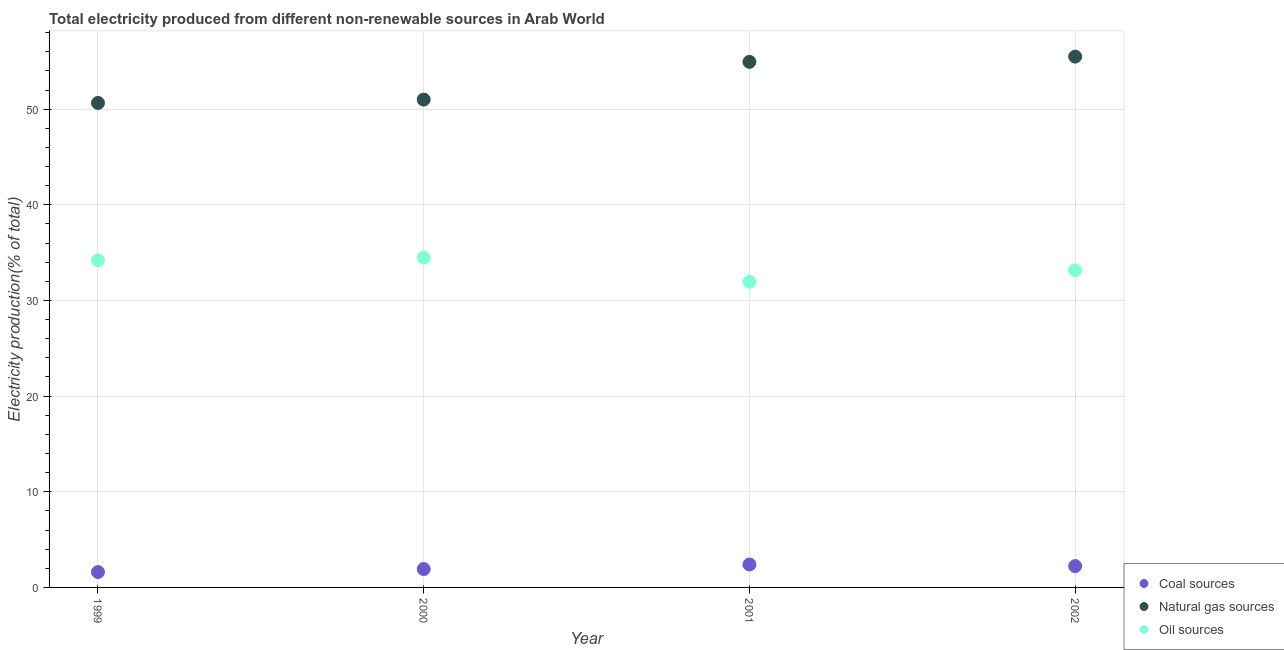What is the percentage of electricity produced by natural gas in 2002?
Offer a terse response. 55.49. Across all years, what is the maximum percentage of electricity produced by natural gas?
Offer a terse response. 55.49. Across all years, what is the minimum percentage of electricity produced by natural gas?
Provide a succinct answer. 50.65. What is the total percentage of electricity produced by oil sources in the graph?
Give a very brief answer. 133.8. What is the difference between the percentage of electricity produced by oil sources in 1999 and that in 2000?
Your response must be concise. -0.27. What is the difference between the percentage of electricity produced by oil sources in 2002 and the percentage of electricity produced by coal in 2000?
Keep it short and to the point. 31.23. What is the average percentage of electricity produced by coal per year?
Provide a short and direct response. 2.04. In the year 2002, what is the difference between the percentage of electricity produced by natural gas and percentage of electricity produced by oil sources?
Ensure brevity in your answer.  22.34. What is the ratio of the percentage of electricity produced by oil sources in 2000 to that in 2002?
Your answer should be very brief. 1.04. What is the difference between the highest and the second highest percentage of electricity produced by natural gas?
Your answer should be very brief. 0.55. What is the difference between the highest and the lowest percentage of electricity produced by natural gas?
Your response must be concise. 4.85. Is the sum of the percentage of electricity produced by oil sources in 1999 and 2001 greater than the maximum percentage of electricity produced by natural gas across all years?
Your answer should be very brief. Yes. Does the percentage of electricity produced by natural gas monotonically increase over the years?
Your answer should be compact. Yes. Are the values on the major ticks of Y-axis written in scientific E-notation?
Offer a very short reply. No. Does the graph contain any zero values?
Provide a short and direct response. No. Does the graph contain grids?
Provide a succinct answer. Yes. Where does the legend appear in the graph?
Keep it short and to the point. Bottom right. How are the legend labels stacked?
Ensure brevity in your answer.  Vertical. What is the title of the graph?
Provide a short and direct response. Total electricity produced from different non-renewable sources in Arab World. What is the label or title of the Y-axis?
Give a very brief answer. Electricity production(% of total). What is the Electricity production(% of total) in Coal sources in 1999?
Ensure brevity in your answer.  1.61. What is the Electricity production(% of total) of Natural gas sources in 1999?
Provide a short and direct response. 50.65. What is the Electricity production(% of total) in Oil sources in 1999?
Your answer should be very brief. 34.21. What is the Electricity production(% of total) of Coal sources in 2000?
Keep it short and to the point. 1.92. What is the Electricity production(% of total) of Natural gas sources in 2000?
Provide a short and direct response. 51. What is the Electricity production(% of total) of Oil sources in 2000?
Offer a very short reply. 34.48. What is the Electricity production(% of total) in Coal sources in 2001?
Provide a succinct answer. 2.4. What is the Electricity production(% of total) of Natural gas sources in 2001?
Provide a succinct answer. 54.94. What is the Electricity production(% of total) in Oil sources in 2001?
Your answer should be compact. 31.96. What is the Electricity production(% of total) of Coal sources in 2002?
Ensure brevity in your answer.  2.23. What is the Electricity production(% of total) in Natural gas sources in 2002?
Provide a short and direct response. 55.49. What is the Electricity production(% of total) of Oil sources in 2002?
Give a very brief answer. 33.15. Across all years, what is the maximum Electricity production(% of total) of Coal sources?
Your answer should be compact. 2.4. Across all years, what is the maximum Electricity production(% of total) of Natural gas sources?
Ensure brevity in your answer.  55.49. Across all years, what is the maximum Electricity production(% of total) of Oil sources?
Provide a succinct answer. 34.48. Across all years, what is the minimum Electricity production(% of total) in Coal sources?
Provide a short and direct response. 1.61. Across all years, what is the minimum Electricity production(% of total) in Natural gas sources?
Your response must be concise. 50.65. Across all years, what is the minimum Electricity production(% of total) in Oil sources?
Offer a terse response. 31.96. What is the total Electricity production(% of total) of Coal sources in the graph?
Your answer should be compact. 8.15. What is the total Electricity production(% of total) in Natural gas sources in the graph?
Your answer should be compact. 212.08. What is the total Electricity production(% of total) of Oil sources in the graph?
Ensure brevity in your answer.  133.8. What is the difference between the Electricity production(% of total) of Coal sources in 1999 and that in 2000?
Give a very brief answer. -0.31. What is the difference between the Electricity production(% of total) in Natural gas sources in 1999 and that in 2000?
Offer a very short reply. -0.35. What is the difference between the Electricity production(% of total) of Oil sources in 1999 and that in 2000?
Your answer should be compact. -0.27. What is the difference between the Electricity production(% of total) of Coal sources in 1999 and that in 2001?
Your answer should be compact. -0.79. What is the difference between the Electricity production(% of total) of Natural gas sources in 1999 and that in 2001?
Give a very brief answer. -4.29. What is the difference between the Electricity production(% of total) of Oil sources in 1999 and that in 2001?
Offer a very short reply. 2.25. What is the difference between the Electricity production(% of total) in Coal sources in 1999 and that in 2002?
Ensure brevity in your answer.  -0.62. What is the difference between the Electricity production(% of total) of Natural gas sources in 1999 and that in 2002?
Your answer should be very brief. -4.85. What is the difference between the Electricity production(% of total) of Oil sources in 1999 and that in 2002?
Your answer should be very brief. 1.06. What is the difference between the Electricity production(% of total) of Coal sources in 2000 and that in 2001?
Provide a short and direct response. -0.48. What is the difference between the Electricity production(% of total) in Natural gas sources in 2000 and that in 2001?
Your response must be concise. -3.94. What is the difference between the Electricity production(% of total) in Oil sources in 2000 and that in 2001?
Provide a short and direct response. 2.52. What is the difference between the Electricity production(% of total) in Coal sources in 2000 and that in 2002?
Give a very brief answer. -0.31. What is the difference between the Electricity production(% of total) in Natural gas sources in 2000 and that in 2002?
Give a very brief answer. -4.49. What is the difference between the Electricity production(% of total) of Oil sources in 2000 and that in 2002?
Give a very brief answer. 1.33. What is the difference between the Electricity production(% of total) of Coal sources in 2001 and that in 2002?
Your response must be concise. 0.17. What is the difference between the Electricity production(% of total) in Natural gas sources in 2001 and that in 2002?
Provide a short and direct response. -0.55. What is the difference between the Electricity production(% of total) of Oil sources in 2001 and that in 2002?
Your answer should be compact. -1.19. What is the difference between the Electricity production(% of total) of Coal sources in 1999 and the Electricity production(% of total) of Natural gas sources in 2000?
Ensure brevity in your answer.  -49.39. What is the difference between the Electricity production(% of total) in Coal sources in 1999 and the Electricity production(% of total) in Oil sources in 2000?
Offer a terse response. -32.87. What is the difference between the Electricity production(% of total) of Natural gas sources in 1999 and the Electricity production(% of total) of Oil sources in 2000?
Offer a terse response. 16.17. What is the difference between the Electricity production(% of total) of Coal sources in 1999 and the Electricity production(% of total) of Natural gas sources in 2001?
Your answer should be very brief. -53.33. What is the difference between the Electricity production(% of total) in Coal sources in 1999 and the Electricity production(% of total) in Oil sources in 2001?
Provide a succinct answer. -30.35. What is the difference between the Electricity production(% of total) of Natural gas sources in 1999 and the Electricity production(% of total) of Oil sources in 2001?
Your response must be concise. 18.69. What is the difference between the Electricity production(% of total) in Coal sources in 1999 and the Electricity production(% of total) in Natural gas sources in 2002?
Offer a very short reply. -53.88. What is the difference between the Electricity production(% of total) in Coal sources in 1999 and the Electricity production(% of total) in Oil sources in 2002?
Give a very brief answer. -31.54. What is the difference between the Electricity production(% of total) in Natural gas sources in 1999 and the Electricity production(% of total) in Oil sources in 2002?
Offer a terse response. 17.5. What is the difference between the Electricity production(% of total) of Coal sources in 2000 and the Electricity production(% of total) of Natural gas sources in 2001?
Ensure brevity in your answer.  -53.02. What is the difference between the Electricity production(% of total) in Coal sources in 2000 and the Electricity production(% of total) in Oil sources in 2001?
Your response must be concise. -30.04. What is the difference between the Electricity production(% of total) of Natural gas sources in 2000 and the Electricity production(% of total) of Oil sources in 2001?
Your answer should be very brief. 19.04. What is the difference between the Electricity production(% of total) of Coal sources in 2000 and the Electricity production(% of total) of Natural gas sources in 2002?
Keep it short and to the point. -53.57. What is the difference between the Electricity production(% of total) of Coal sources in 2000 and the Electricity production(% of total) of Oil sources in 2002?
Offer a terse response. -31.23. What is the difference between the Electricity production(% of total) of Natural gas sources in 2000 and the Electricity production(% of total) of Oil sources in 2002?
Offer a very short reply. 17.85. What is the difference between the Electricity production(% of total) of Coal sources in 2001 and the Electricity production(% of total) of Natural gas sources in 2002?
Give a very brief answer. -53.09. What is the difference between the Electricity production(% of total) of Coal sources in 2001 and the Electricity production(% of total) of Oil sources in 2002?
Make the answer very short. -30.75. What is the difference between the Electricity production(% of total) in Natural gas sources in 2001 and the Electricity production(% of total) in Oil sources in 2002?
Make the answer very short. 21.79. What is the average Electricity production(% of total) of Coal sources per year?
Offer a terse response. 2.04. What is the average Electricity production(% of total) of Natural gas sources per year?
Your answer should be very brief. 53.02. What is the average Electricity production(% of total) of Oil sources per year?
Ensure brevity in your answer.  33.45. In the year 1999, what is the difference between the Electricity production(% of total) in Coal sources and Electricity production(% of total) in Natural gas sources?
Keep it short and to the point. -49.04. In the year 1999, what is the difference between the Electricity production(% of total) of Coal sources and Electricity production(% of total) of Oil sources?
Your response must be concise. -32.6. In the year 1999, what is the difference between the Electricity production(% of total) of Natural gas sources and Electricity production(% of total) of Oil sources?
Make the answer very short. 16.44. In the year 2000, what is the difference between the Electricity production(% of total) of Coal sources and Electricity production(% of total) of Natural gas sources?
Provide a succinct answer. -49.08. In the year 2000, what is the difference between the Electricity production(% of total) of Coal sources and Electricity production(% of total) of Oil sources?
Your answer should be compact. -32.56. In the year 2000, what is the difference between the Electricity production(% of total) in Natural gas sources and Electricity production(% of total) in Oil sources?
Offer a terse response. 16.52. In the year 2001, what is the difference between the Electricity production(% of total) in Coal sources and Electricity production(% of total) in Natural gas sources?
Provide a succinct answer. -52.54. In the year 2001, what is the difference between the Electricity production(% of total) of Coal sources and Electricity production(% of total) of Oil sources?
Offer a terse response. -29.56. In the year 2001, what is the difference between the Electricity production(% of total) in Natural gas sources and Electricity production(% of total) in Oil sources?
Offer a terse response. 22.98. In the year 2002, what is the difference between the Electricity production(% of total) of Coal sources and Electricity production(% of total) of Natural gas sources?
Keep it short and to the point. -53.26. In the year 2002, what is the difference between the Electricity production(% of total) of Coal sources and Electricity production(% of total) of Oil sources?
Your answer should be very brief. -30.92. In the year 2002, what is the difference between the Electricity production(% of total) of Natural gas sources and Electricity production(% of total) of Oil sources?
Your response must be concise. 22.34. What is the ratio of the Electricity production(% of total) in Coal sources in 1999 to that in 2000?
Keep it short and to the point. 0.84. What is the ratio of the Electricity production(% of total) of Oil sources in 1999 to that in 2000?
Make the answer very short. 0.99. What is the ratio of the Electricity production(% of total) of Coal sources in 1999 to that in 2001?
Make the answer very short. 0.67. What is the ratio of the Electricity production(% of total) in Natural gas sources in 1999 to that in 2001?
Provide a succinct answer. 0.92. What is the ratio of the Electricity production(% of total) of Oil sources in 1999 to that in 2001?
Make the answer very short. 1.07. What is the ratio of the Electricity production(% of total) in Coal sources in 1999 to that in 2002?
Ensure brevity in your answer.  0.72. What is the ratio of the Electricity production(% of total) in Natural gas sources in 1999 to that in 2002?
Provide a succinct answer. 0.91. What is the ratio of the Electricity production(% of total) of Oil sources in 1999 to that in 2002?
Ensure brevity in your answer.  1.03. What is the ratio of the Electricity production(% of total) in Coal sources in 2000 to that in 2001?
Provide a succinct answer. 0.8. What is the ratio of the Electricity production(% of total) in Natural gas sources in 2000 to that in 2001?
Offer a terse response. 0.93. What is the ratio of the Electricity production(% of total) in Oil sources in 2000 to that in 2001?
Provide a short and direct response. 1.08. What is the ratio of the Electricity production(% of total) in Coal sources in 2000 to that in 2002?
Provide a short and direct response. 0.86. What is the ratio of the Electricity production(% of total) in Natural gas sources in 2000 to that in 2002?
Your answer should be compact. 0.92. What is the ratio of the Electricity production(% of total) in Oil sources in 2000 to that in 2002?
Provide a short and direct response. 1.04. What is the ratio of the Electricity production(% of total) of Coal sources in 2001 to that in 2002?
Ensure brevity in your answer.  1.07. What is the ratio of the Electricity production(% of total) in Oil sources in 2001 to that in 2002?
Offer a very short reply. 0.96. What is the difference between the highest and the second highest Electricity production(% of total) of Coal sources?
Your answer should be very brief. 0.17. What is the difference between the highest and the second highest Electricity production(% of total) of Natural gas sources?
Give a very brief answer. 0.55. What is the difference between the highest and the second highest Electricity production(% of total) in Oil sources?
Keep it short and to the point. 0.27. What is the difference between the highest and the lowest Electricity production(% of total) of Coal sources?
Offer a very short reply. 0.79. What is the difference between the highest and the lowest Electricity production(% of total) of Natural gas sources?
Your answer should be very brief. 4.85. What is the difference between the highest and the lowest Electricity production(% of total) of Oil sources?
Your answer should be compact. 2.52. 